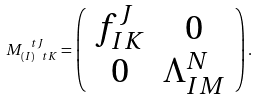<formula> <loc_0><loc_0><loc_500><loc_500>M _ { ( I ) \ t K } ^ { \ t J } = \left ( \begin{array} { c c } f _ { I K } ^ { J } & 0 \\ 0 & \Lambda _ { I M } ^ { N } \end{array} \right ) .</formula> 